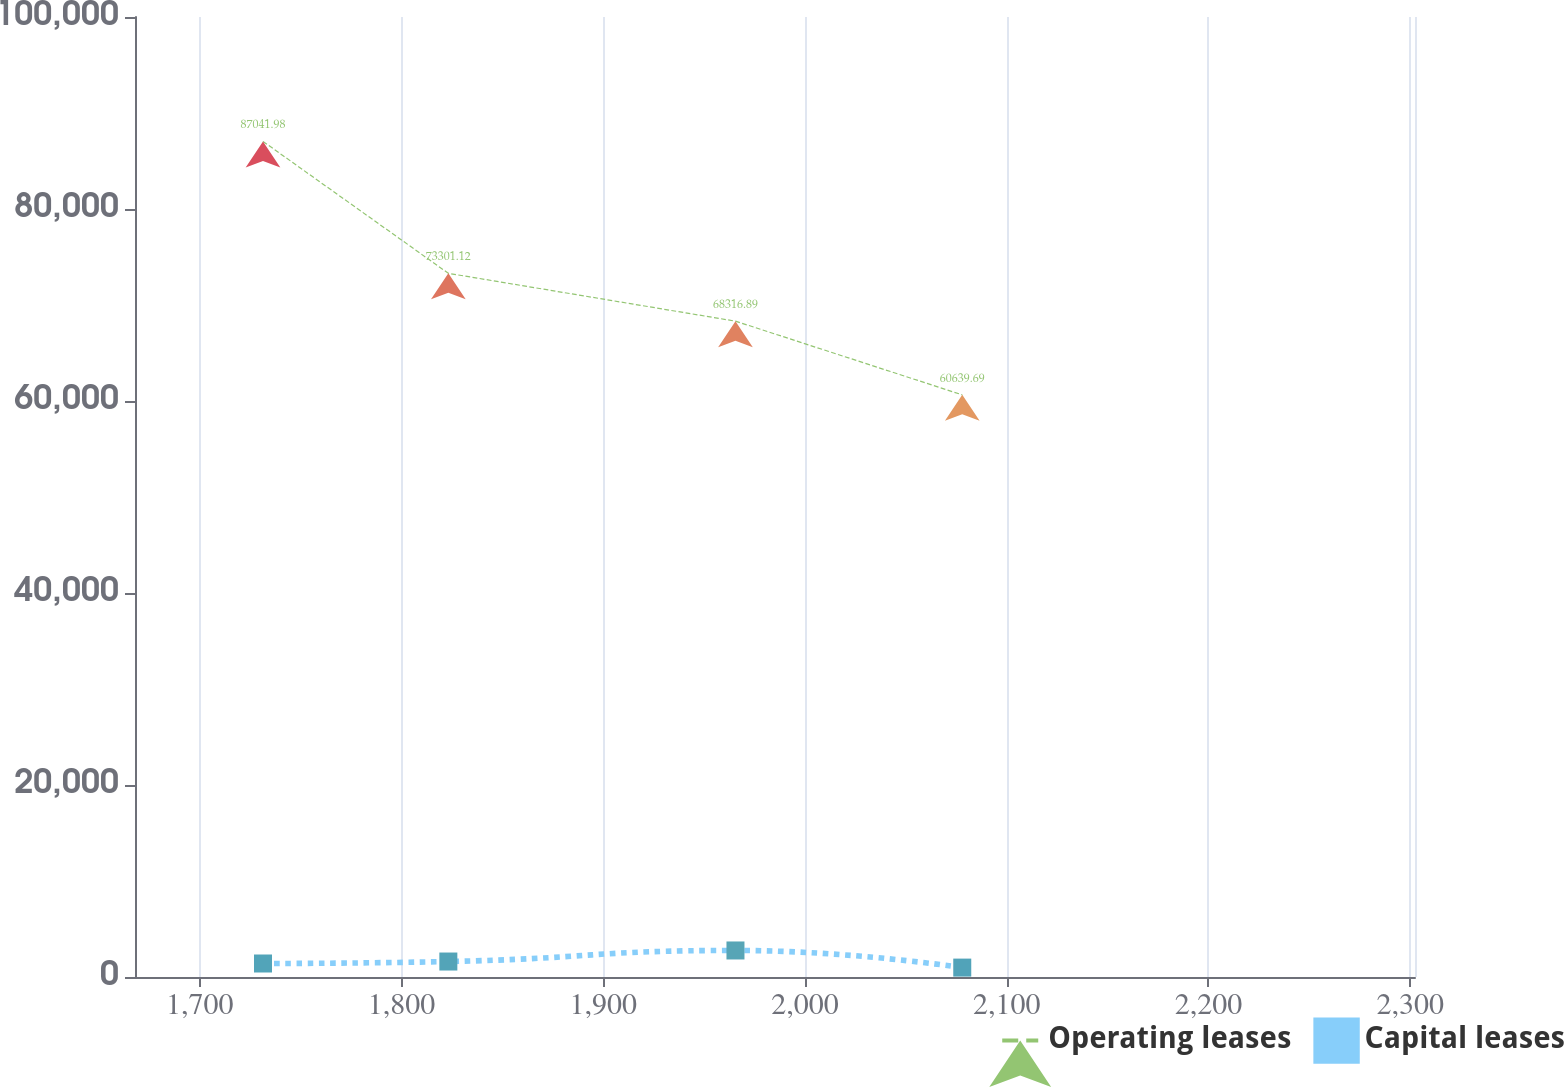Convert chart to OTSL. <chart><loc_0><loc_0><loc_500><loc_500><line_chart><ecel><fcel>Operating leases<fcel>Capital leases<nl><fcel>1731.36<fcel>87042<fcel>1406.21<nl><fcel>1823.23<fcel>73301.1<fcel>1611.9<nl><fcel>1965.55<fcel>68316.9<fcel>2763.39<nl><fcel>2077.96<fcel>60639.7<fcel>978.85<nl><fcel>2365.82<fcel>37199.7<fcel>706.44<nl></chart> 